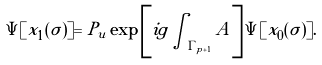Convert formula to latex. <formula><loc_0><loc_0><loc_500><loc_500>\Psi [ x _ { 1 } ( \sigma ) ] = P _ { u } \exp \left [ i g \int _ { \Gamma _ { p + 1 } } A \right ] \Psi [ x _ { 0 } ( \sigma ) ] .</formula> 